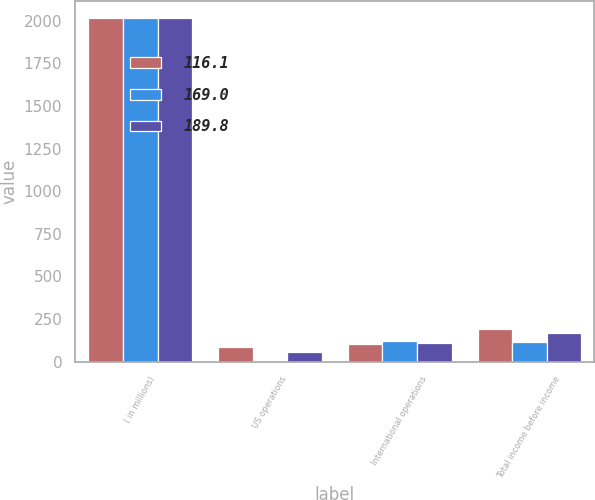<chart> <loc_0><loc_0><loc_500><loc_500><stacked_bar_chart><ecel><fcel>( in millions)<fcel>US operations<fcel>International operations<fcel>Total income before income<nl><fcel>116.1<fcel>2016<fcel>84.5<fcel>105.3<fcel>189.8<nl><fcel>169<fcel>2015<fcel>4<fcel>120.1<fcel>116.1<nl><fcel>189.8<fcel>2014<fcel>57.5<fcel>111.5<fcel>169<nl></chart> 